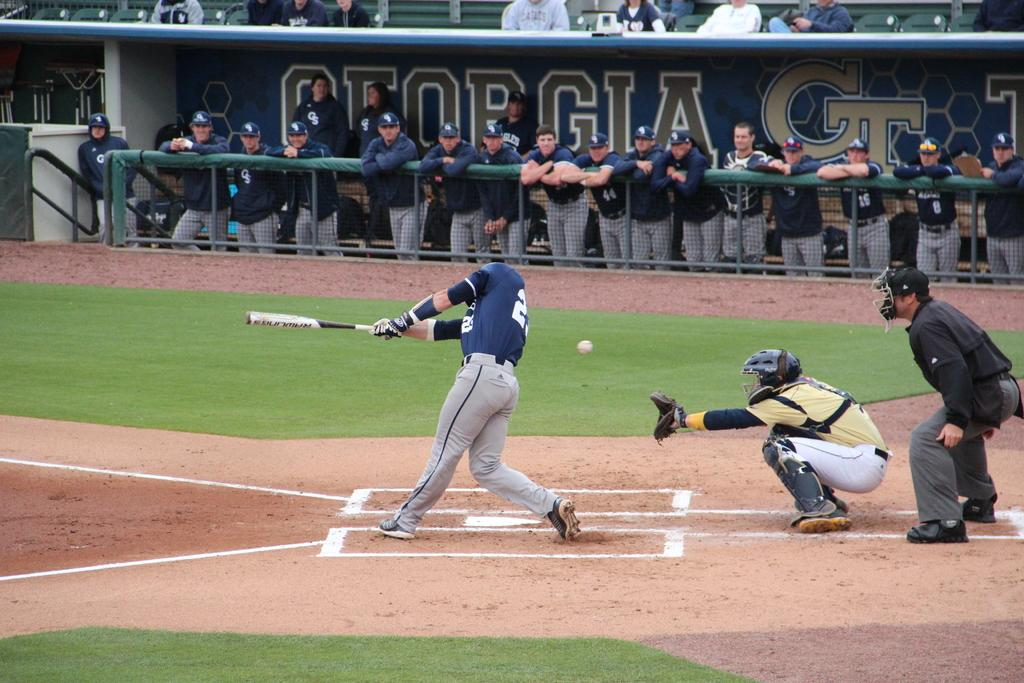Provide a one-sentence caption for the provided image. Georgia Tech batter swings and misses while on the plate. 